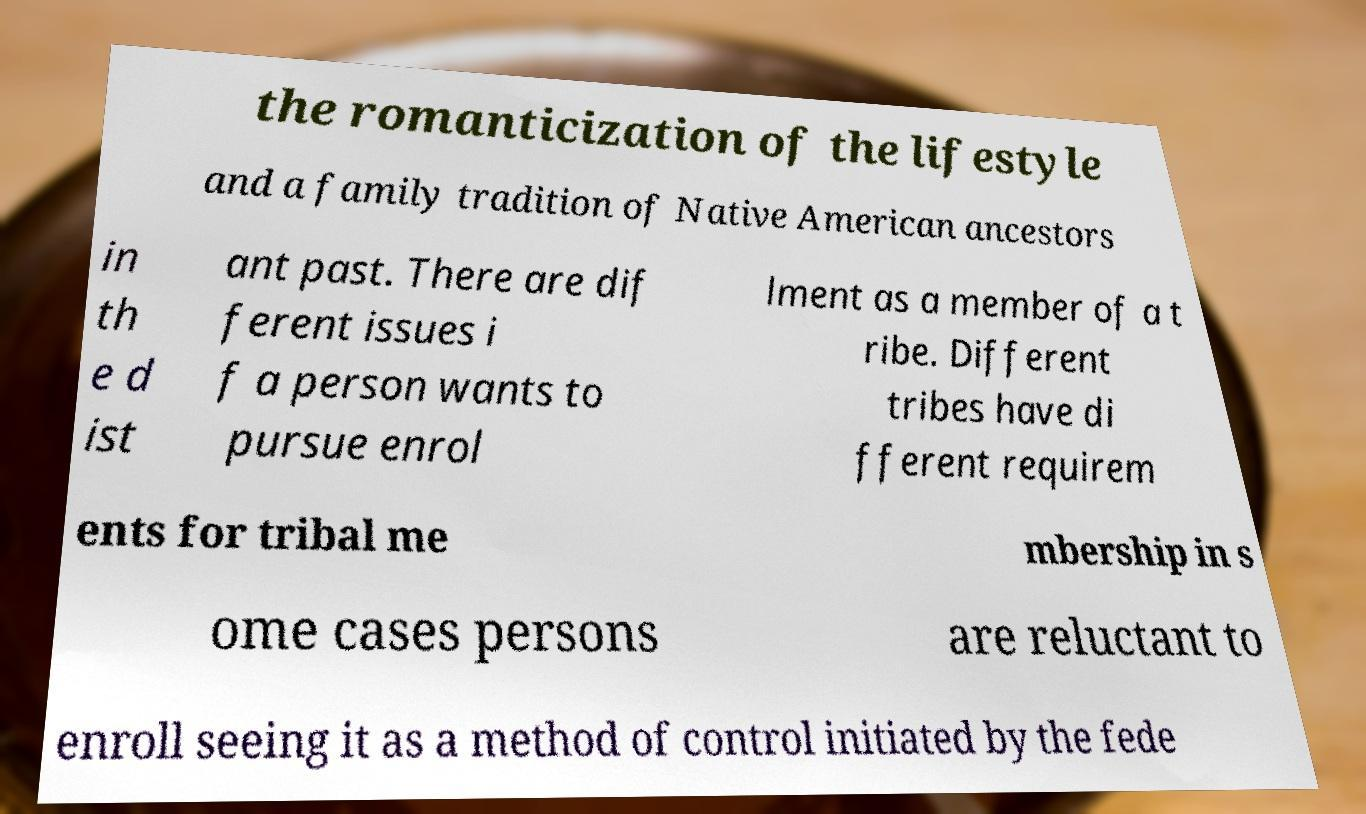There's text embedded in this image that I need extracted. Can you transcribe it verbatim? the romanticization of the lifestyle and a family tradition of Native American ancestors in th e d ist ant past. There are dif ferent issues i f a person wants to pursue enrol lment as a member of a t ribe. Different tribes have di fferent requirem ents for tribal me mbership in s ome cases persons are reluctant to enroll seeing it as a method of control initiated by the fede 